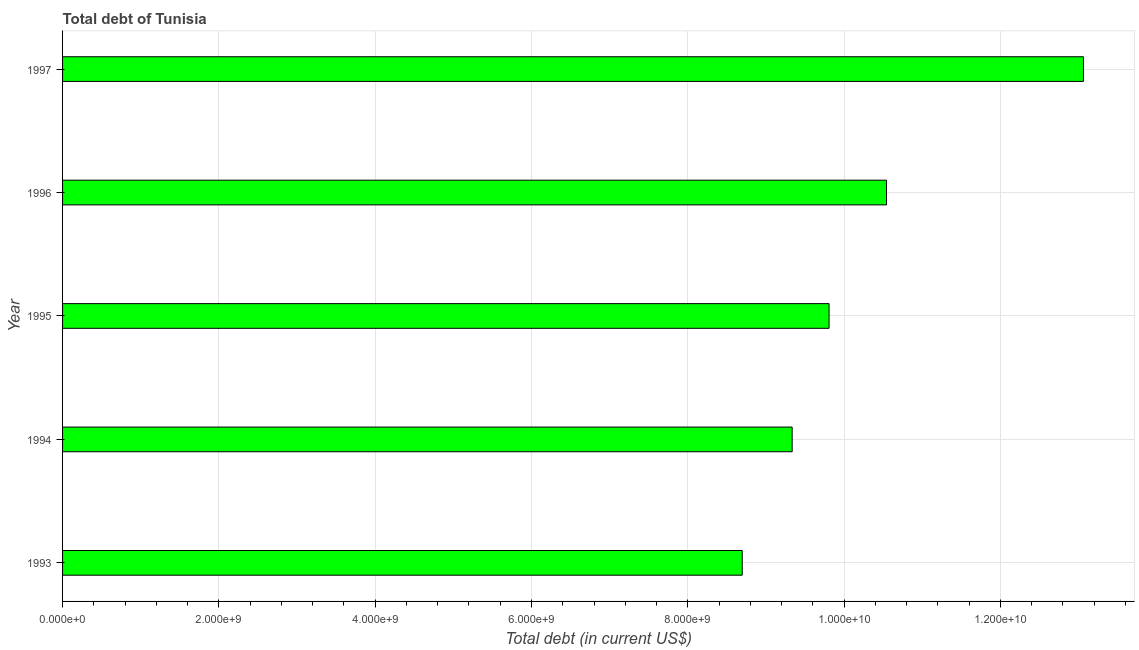What is the title of the graph?
Give a very brief answer. Total debt of Tunisia. What is the label or title of the X-axis?
Your answer should be very brief. Total debt (in current US$). What is the total debt in 1993?
Provide a succinct answer. 8.70e+09. Across all years, what is the maximum total debt?
Your answer should be compact. 1.31e+1. Across all years, what is the minimum total debt?
Your answer should be very brief. 8.70e+09. In which year was the total debt minimum?
Offer a very short reply. 1993. What is the sum of the total debt?
Provide a short and direct response. 5.14e+1. What is the difference between the total debt in 1995 and 1996?
Ensure brevity in your answer.  -7.35e+08. What is the average total debt per year?
Provide a short and direct response. 1.03e+1. What is the median total debt?
Provide a succinct answer. 9.81e+09. In how many years, is the total debt greater than 2800000000 US$?
Make the answer very short. 5. What is the ratio of the total debt in 1994 to that in 1996?
Your answer should be very brief. 0.89. What is the difference between the highest and the second highest total debt?
Provide a succinct answer. 2.52e+09. What is the difference between the highest and the lowest total debt?
Your response must be concise. 4.37e+09. In how many years, is the total debt greater than the average total debt taken over all years?
Offer a terse response. 2. Are all the bars in the graph horizontal?
Your response must be concise. Yes. What is the Total debt (in current US$) in 1993?
Offer a terse response. 8.70e+09. What is the Total debt (in current US$) in 1994?
Offer a terse response. 9.34e+09. What is the Total debt (in current US$) of 1995?
Make the answer very short. 9.81e+09. What is the Total debt (in current US$) of 1996?
Offer a very short reply. 1.05e+1. What is the Total debt (in current US$) in 1997?
Offer a very short reply. 1.31e+1. What is the difference between the Total debt (in current US$) in 1993 and 1994?
Keep it short and to the point. -6.39e+08. What is the difference between the Total debt (in current US$) in 1993 and 1995?
Keep it short and to the point. -1.11e+09. What is the difference between the Total debt (in current US$) in 1993 and 1996?
Provide a succinct answer. -1.85e+09. What is the difference between the Total debt (in current US$) in 1993 and 1997?
Your answer should be very brief. -4.37e+09. What is the difference between the Total debt (in current US$) in 1994 and 1995?
Offer a terse response. -4.72e+08. What is the difference between the Total debt (in current US$) in 1994 and 1996?
Keep it short and to the point. -1.21e+09. What is the difference between the Total debt (in current US$) in 1994 and 1997?
Your response must be concise. -3.73e+09. What is the difference between the Total debt (in current US$) in 1995 and 1996?
Provide a short and direct response. -7.35e+08. What is the difference between the Total debt (in current US$) in 1995 and 1997?
Make the answer very short. -3.26e+09. What is the difference between the Total debt (in current US$) in 1996 and 1997?
Ensure brevity in your answer.  -2.52e+09. What is the ratio of the Total debt (in current US$) in 1993 to that in 1994?
Your response must be concise. 0.93. What is the ratio of the Total debt (in current US$) in 1993 to that in 1995?
Your response must be concise. 0.89. What is the ratio of the Total debt (in current US$) in 1993 to that in 1996?
Offer a terse response. 0.82. What is the ratio of the Total debt (in current US$) in 1993 to that in 1997?
Offer a very short reply. 0.67. What is the ratio of the Total debt (in current US$) in 1994 to that in 1995?
Your response must be concise. 0.95. What is the ratio of the Total debt (in current US$) in 1994 to that in 1996?
Offer a very short reply. 0.89. What is the ratio of the Total debt (in current US$) in 1994 to that in 1997?
Make the answer very short. 0.71. What is the ratio of the Total debt (in current US$) in 1995 to that in 1997?
Your response must be concise. 0.75. What is the ratio of the Total debt (in current US$) in 1996 to that in 1997?
Offer a very short reply. 0.81. 